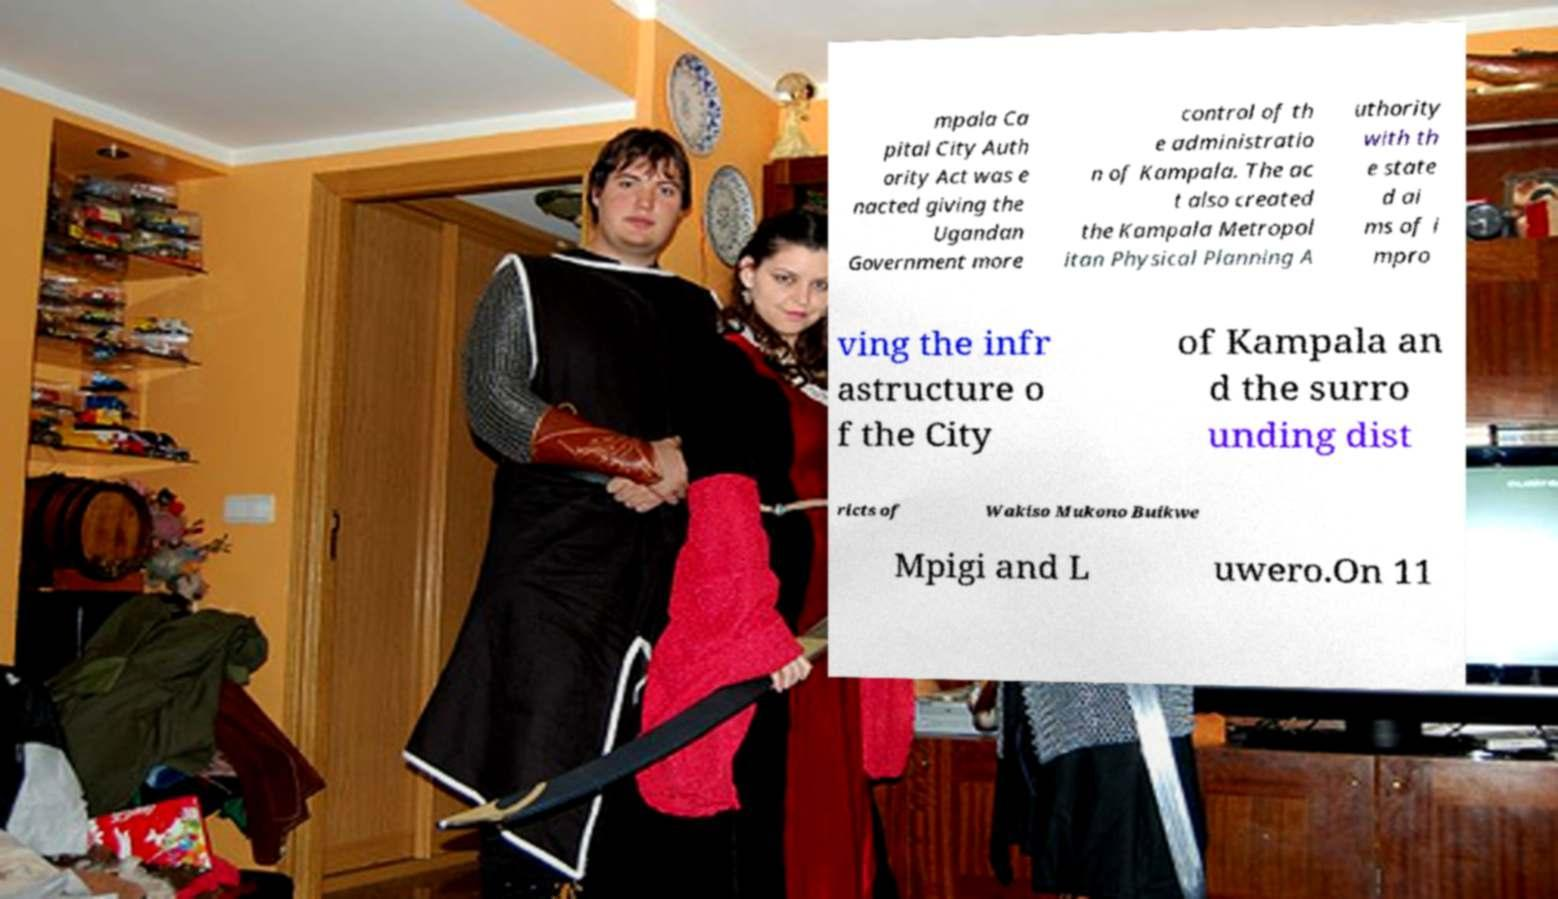Please identify and transcribe the text found in this image. mpala Ca pital City Auth ority Act was e nacted giving the Ugandan Government more control of th e administratio n of Kampala. The ac t also created the Kampala Metropol itan Physical Planning A uthority with th e state d ai ms of i mpro ving the infr astructure o f the City of Kampala an d the surro unding dist ricts of Wakiso Mukono Buikwe Mpigi and L uwero.On 11 